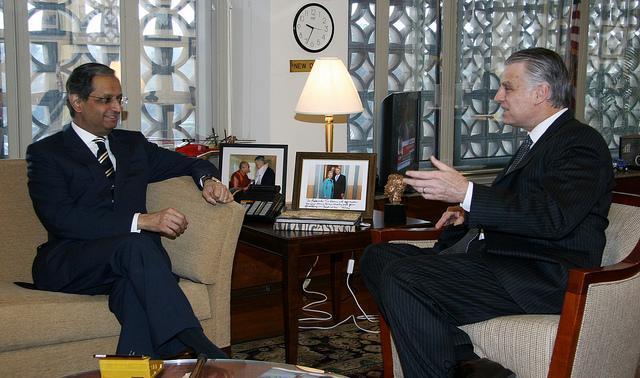How many chairs are visible?
Give a very brief answer. 2. How many people are there?
Give a very brief answer. 2. How many cups on the table are empty?
Give a very brief answer. 0. 